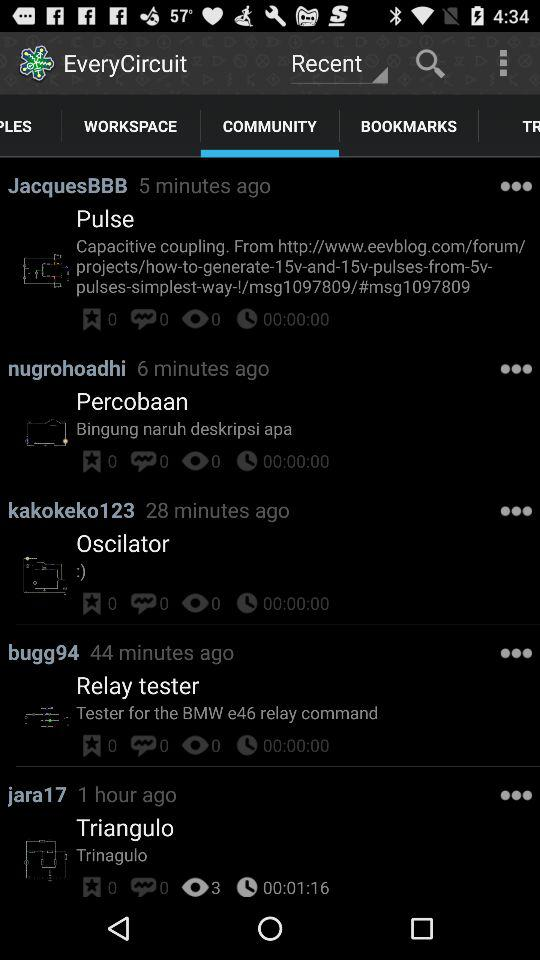How many hours ago did "jara17" post? "jara17" posted 1 hour ago. 